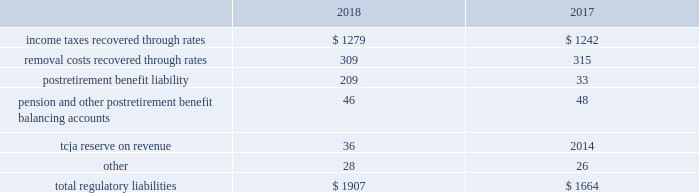Pre-construction costs , interim dam safety measures and environmental costs and construction costs .
The authorized costs were being recovered via a surcharge over a twenty-year period which began in october 2012 .
The unrecovered balance of project costs incurred , including cost of capital , net of surcharges totaled $ 85 million and $ 89 million as of december 31 , 2018 and 2017 , respectively .
Surcharges collected were $ 8 million and $ 7 million for the years ended december 31 , 2018 and 2017 , respectively .
Pursuant to the general rate case approved in december 2018 , approval was granted to reset the twenty-year amortization period to begin january 1 , 2018 and to establish an annual revenue requirement of $ 8 million to be recovered through base rates .
Debt expense is amortized over the lives of the respective issues .
Call premiums on the redemption of long- term debt , as well as unamortized debt expense , are deferred and amortized to the extent they will be recovered through future service rates .
Purchase premium recoverable through rates is primarily the recovery of the acquisition premiums related to an asset acquisition by the company 2019s utility subsidiary in california during 2002 , and acquisitions in 2007 by the company 2019s utility subsidiary in new jersey .
As authorized for recovery by the california and new jersey pucs , these costs are being amortized to depreciation and amortization on the consolidated statements of operations through november 2048 .
Tank painting costs are generally deferred and amortized to operations and maintenance expense on the consolidated statements of operations on a straight-line basis over periods ranging from five to fifteen years , as authorized by the regulatory authorities in their determination of rates charged for service .
As a result of the prepayment by american water capital corp. , the company 2019s wholly owned finance subsidiary ( 201cawcc 201d ) , of the 5.62% ( 5.62 % ) series c senior notes due upon maturity on december 21 , 2018 ( the 201cseries c notes 201d ) , 5.62% ( 5.62 % ) series e senior notes due march 29 , 2019 ( the 201cseries e notes 201d ) and 5.77% ( 5.77 % ) series f senior notes due december 21 , 2022 ( the 201cseries f notes , 201d and together with the series e notes , the 201cseries notes 201d ) , a make-whole premium of $ 10 million was paid to the holders of the series notes on september 11 , 2018 .
Substantially all of these early debt extinguishment costs were allocable to the company 2019s utility subsidiaries and recorded as regulatory assets , as the company believes they are probable of recovery in future rates .
Other regulatory assets include certain construction costs for treatment facilities , property tax stabilization , employee-related costs , deferred other postretirement benefit expense , business services project expenses , coastal water project costs , rate case expenditures and environmental remediation costs among others .
These costs are deferred because the amounts are being recovered in rates or are probable of recovery through rates in future periods .
Regulatory liabilities regulatory liabilities generally represent amounts that are probable of being credited or refunded to customers through the rate-making process .
Also , if costs expected to be incurred in the future are currently being recovered through rates , the company records those expected future costs as regulatory liabilities .
The table provides the composition of regulatory liabilities as of december 31: .

What was the change in postretirement benefit liability in millions? 
Computations: (209 - 33)
Answer: 176.0. Pre-construction costs , interim dam safety measures and environmental costs and construction costs .
The authorized costs were being recovered via a surcharge over a twenty-year period which began in october 2012 .
The unrecovered balance of project costs incurred , including cost of capital , net of surcharges totaled $ 85 million and $ 89 million as of december 31 , 2018 and 2017 , respectively .
Surcharges collected were $ 8 million and $ 7 million for the years ended december 31 , 2018 and 2017 , respectively .
Pursuant to the general rate case approved in december 2018 , approval was granted to reset the twenty-year amortization period to begin january 1 , 2018 and to establish an annual revenue requirement of $ 8 million to be recovered through base rates .
Debt expense is amortized over the lives of the respective issues .
Call premiums on the redemption of long- term debt , as well as unamortized debt expense , are deferred and amortized to the extent they will be recovered through future service rates .
Purchase premium recoverable through rates is primarily the recovery of the acquisition premiums related to an asset acquisition by the company 2019s utility subsidiary in california during 2002 , and acquisitions in 2007 by the company 2019s utility subsidiary in new jersey .
As authorized for recovery by the california and new jersey pucs , these costs are being amortized to depreciation and amortization on the consolidated statements of operations through november 2048 .
Tank painting costs are generally deferred and amortized to operations and maintenance expense on the consolidated statements of operations on a straight-line basis over periods ranging from five to fifteen years , as authorized by the regulatory authorities in their determination of rates charged for service .
As a result of the prepayment by american water capital corp. , the company 2019s wholly owned finance subsidiary ( 201cawcc 201d ) , of the 5.62% ( 5.62 % ) series c senior notes due upon maturity on december 21 , 2018 ( the 201cseries c notes 201d ) , 5.62% ( 5.62 % ) series e senior notes due march 29 , 2019 ( the 201cseries e notes 201d ) and 5.77% ( 5.77 % ) series f senior notes due december 21 , 2022 ( the 201cseries f notes , 201d and together with the series e notes , the 201cseries notes 201d ) , a make-whole premium of $ 10 million was paid to the holders of the series notes on september 11 , 2018 .
Substantially all of these early debt extinguishment costs were allocable to the company 2019s utility subsidiaries and recorded as regulatory assets , as the company believes they are probable of recovery in future rates .
Other regulatory assets include certain construction costs for treatment facilities , property tax stabilization , employee-related costs , deferred other postretirement benefit expense , business services project expenses , coastal water project costs , rate case expenditures and environmental remediation costs among others .
These costs are deferred because the amounts are being recovered in rates or are probable of recovery through rates in future periods .
Regulatory liabilities regulatory liabilities generally represent amounts that are probable of being credited or refunded to customers through the rate-making process .
Also , if costs expected to be incurred in the future are currently being recovered through rates , the company records those expected future costs as regulatory liabilities .
The table provides the composition of regulatory liabilities as of december 31: .

By how much did the unrecovered balance of project costs incurred decrease from 2017 to 2018? 
Computations: ((89 - 85) / 89)
Answer: 0.04494. 